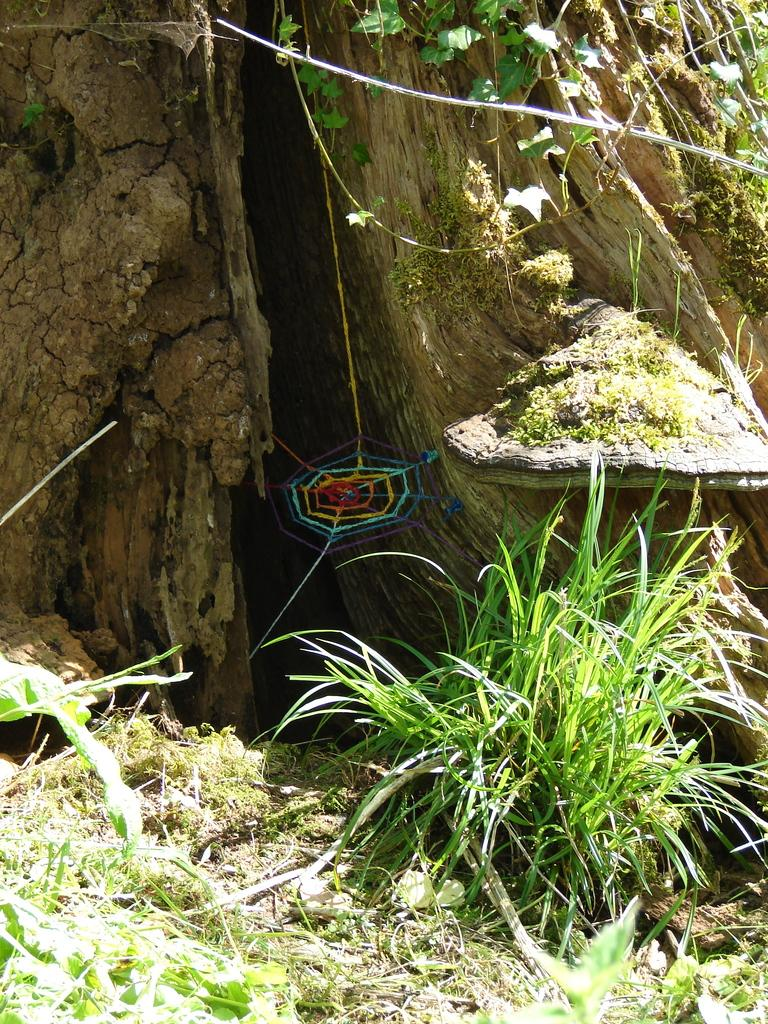What type of vegetation can be seen in the image? There is grass and plants in the image. Are there any structures or natural formations in the image? Yes, there is a spider web and a trunk (possibly a tree trunk) in the image. What type of yarn is being used to create the spider web in the image? There is no yarn present in the image; the spider web is a natural formation created by a spider. Can you see a kite flying in the image? There is no kite present in the image. 